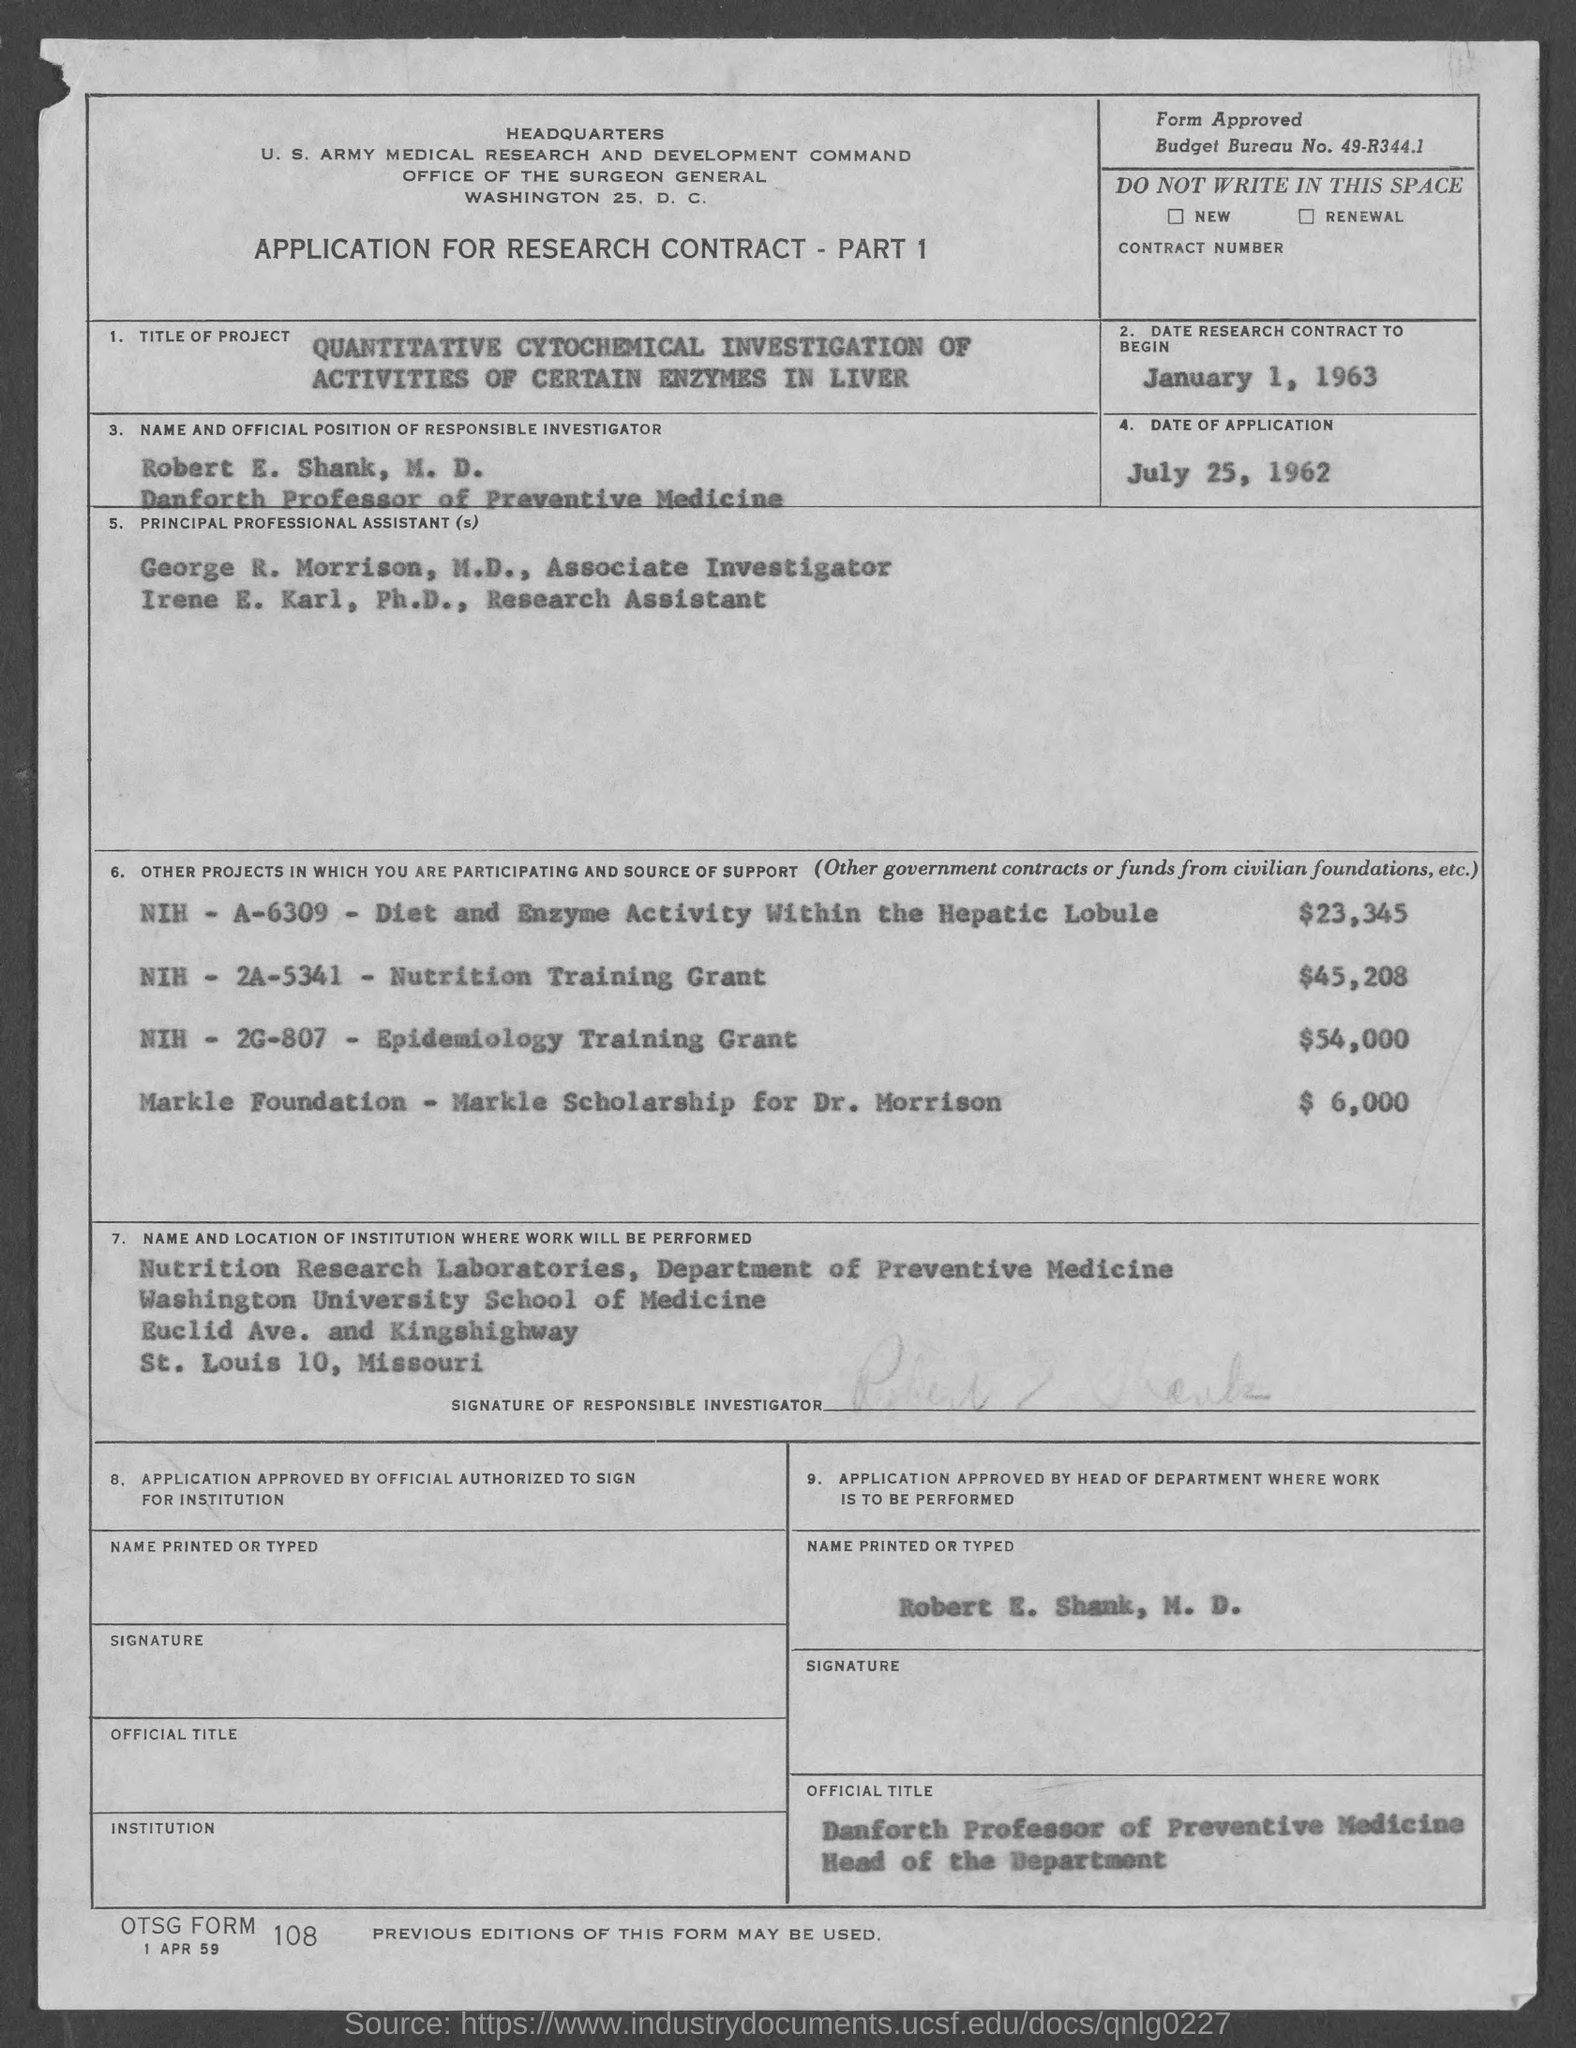Draw attention to some important aspects in this diagram. Robert E. Shank, M.D. is the Danforth Professor of Preventive Medicine. The date of application is July 25, 1962. The budget bureau number is 49-R344.1. George R. Morrison, M.D. holds the position of associate investigator. The date of the research contract is January 1, 1963. 